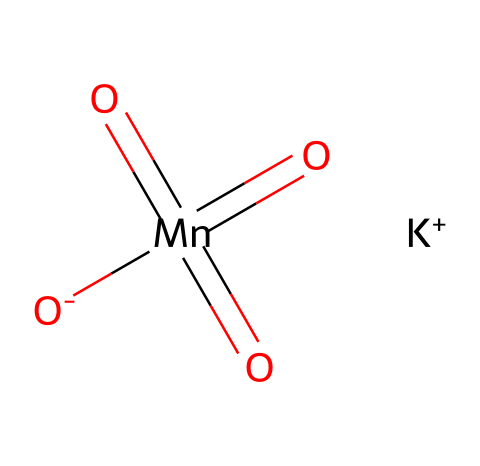What is the central atom in potassium permanganate? In the provided SMILES representation, the central atom is indicated by [Mn], which denotes manganese. As manganese is the atom surrounded by the oxygen atoms and is appreciably bonded to them, it can be identified as the central atom of the compound.
Answer: manganese How many oxygen atoms are present in potassium permanganate? The SMILES representation contains the notation [O] and indicates four oxygen atoms connected to manganese (one with a negative charge and three double bonded). By counting these representations, we confirm that there are a total of four oxygen atoms.
Answer: four What is the oxidation state of manganese in potassium permanganate? The manganese ion in potassium permanganate exhibits a +7 oxidation state, as inferred from its bonding with four oxygen atoms (known for contributing a -2 charge for double bonds). The manganese's effective charge results from the balance needed to achieve charge neutrality in this ion.
Answer: +7 What type of compound is potassium permanganate? Potassium permanganate is classified as an oxidizing agent. Its chemical structure, with high oxidation states of manganese, allows it to accept electrons from other substances. As a result, it is often utilized in applications that require oxidation reactions.
Answer: oxidizing agent Which component of potassium permanganate acts to maintain the water quality in aquariums? The manganese component plays a crucial role in maintaining water quality as an oxidizer, which helps reduce toxins and improve the overall health of the aquatic environment. Since manganese's ability to release oxygen makes it especially effective in these applications, it is a vital element in maintaining aquatic ecosystems.
Answer: manganese What charge does the potassium ion carry in potassium permanganate? The potassium ion, represented by [K+], carries a single positive charge. This is indicated by the "+" sign next to the K symbol, meaning it is a cation, which balances the overall negative contributions from the other species in the compound.
Answer: +1 